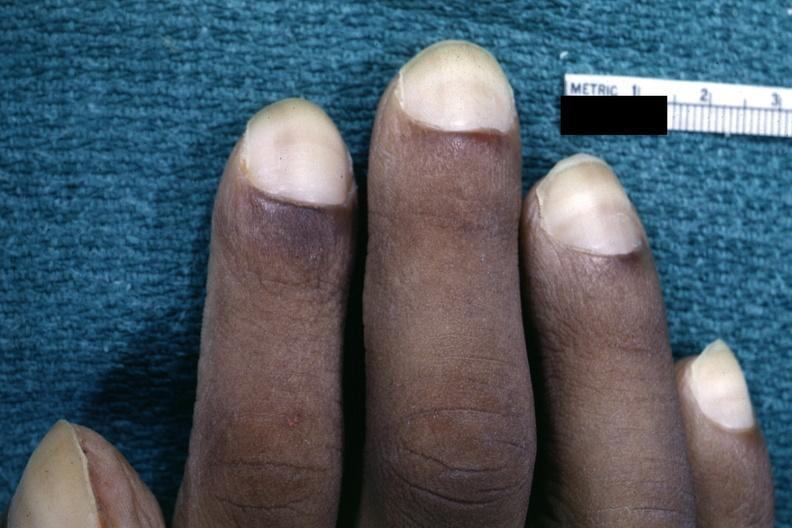s hand present?
Answer the question using a single word or phrase. Yes 